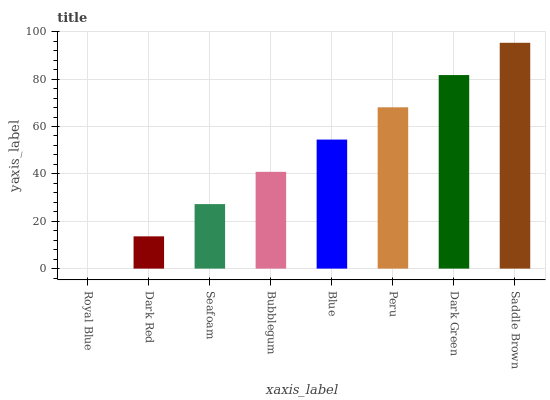Is Dark Red the minimum?
Answer yes or no. No. Is Dark Red the maximum?
Answer yes or no. No. Is Dark Red greater than Royal Blue?
Answer yes or no. Yes. Is Royal Blue less than Dark Red?
Answer yes or no. Yes. Is Royal Blue greater than Dark Red?
Answer yes or no. No. Is Dark Red less than Royal Blue?
Answer yes or no. No. Is Blue the high median?
Answer yes or no. Yes. Is Bubblegum the low median?
Answer yes or no. Yes. Is Peru the high median?
Answer yes or no. No. Is Blue the low median?
Answer yes or no. No. 